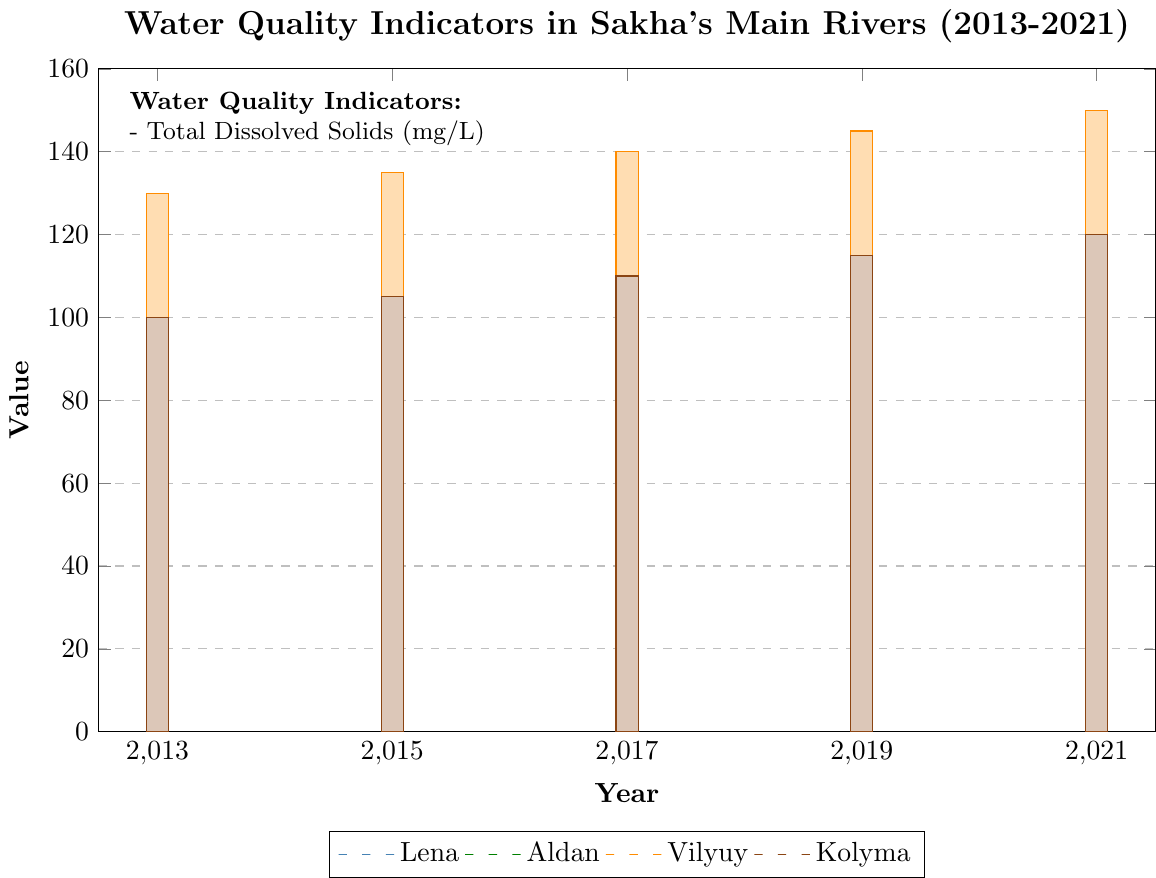Which river had the highest Total Dissolved Solids (TDS) in 2021? Look at the bar heights for the year 2021. The Vilyuy River has the highest TDS value.
Answer: Vilyuy By how much did the Total Dissolved Solids (TDS) increase in the Lena River from 2013 to 2021? Subtract the TDS value of Lena in 2013 (120 mg/L) from the TDS value in 2021 (140 mg/L). The increase is 140 - 120 = 20 mg/L.
Answer: 20 mg/L Which river showed the smallest increase in Total Dissolved Solids (TDS) over the decade? Compare the increase in TDS from 2013 to 2021 for all rivers. Kolyma increased from 100 mg/L to 120 mg/L, which is the smallest increase (20 mg/L).
Answer: Kolyma What is the average Total Dissolved Solids (TDS) value for the Aldan River over the given years? Sum the TDS values for Aldan (110, 115, 120, 125, 130) and divide by the number of data points (5). Calculate the average as (110+115+120+125+130)/5 = 600/5 = 120 mg/L.
Answer: 120 mg/L Which river had the lowest Total Dissolved Solids (TDS) value in 2019? Look at the bar heights for the year 2019. The Kolyma River has the lowest TDS value in 2019, at 115 mg/L.
Answer: Kolyma Compare the Total Dissolved Solids (TDS) of Lena and Kolyma in 2015. Which river had a higher value and by how much? Lena had a TDS of 125 mg/L in 2015, while Kolyma had a TDS of 105 mg/L in 2015. The difference is 125 - 105 = 20 mg/L, so Lena had a higher TDS by 20 mg/L.
Answer: Lena by 20 mg/L What is the trend of Total Dissolved Solids (TDS) in the Vilyuy River from 2013 to 2021? Observe the Vilyuy bar heights from 2013 to 2021. The TDS value shows an increasing trend (130, 135, 140, 145, 150 mg/L) over the years.
Answer: Increasing Between the years 2017 and 2019, which river had the largest increase in Total Dissolved Solids (TDS)? Calculate the increase for each river and compare. Lena: 135-130=5 mg/L, Aldan: 125-120=5 mg/L, Vilyuy: 145-140=5 mg/L, Kolyma: 115-110=5 mg/L. All rivers had the same increase of 5 mg/L.
Answer: All rivers by 5 mg/L 